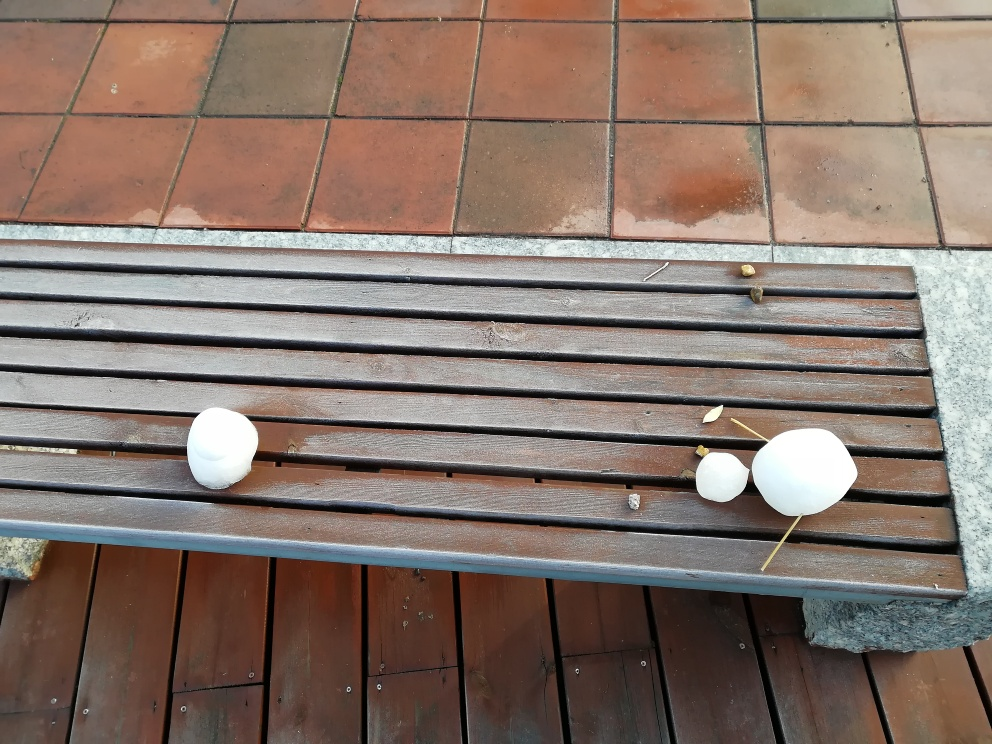What story could be interpreted from the arrangement of these objects on the bench? The arrangement of the two whole eggs and egg shells on the bench might suggest a creative or playful setup, possibly symbolic of hatching new ideas or breaking out of the ordinary. It could also be seen as an impromptu art installation by someone, drawing attention to the simplicity yet intriguing nature of everyday objects. 